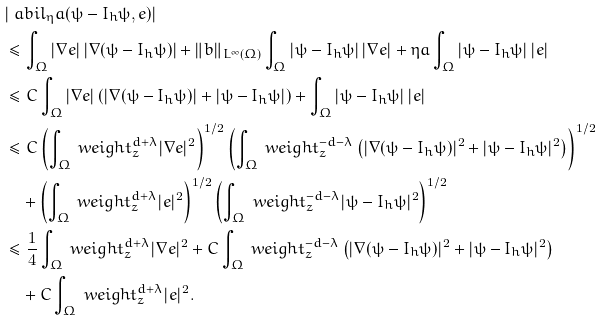Convert formula to latex. <formula><loc_0><loc_0><loc_500><loc_500>& | \ a b i l _ { \eta } a ( \psi - I _ { h } \psi , e ) | \\ & \leq \int _ { \Omega } | \nabla e | \, | \nabla ( \psi - I _ { h } \psi ) | + \| b \| _ { L ^ { \infty } ( \Omega ) } \int _ { \Omega } | \psi - I _ { h } \psi | \, | \nabla e | + \eta a \int _ { \Omega } | \psi - I _ { h } \psi | \, | e | \\ & \leq C \int _ { \Omega } | \nabla e | \left ( | \nabla ( \psi - I _ { h } \psi ) | + | \psi - I _ { h } \psi | \right ) + \int _ { \Omega } | \psi - I _ { h } \psi | \, | e | \\ & \leq C \left ( \int _ { \Omega } \ w e i g h t _ { z } ^ { d + \lambda } | \nabla e | ^ { 2 } \right ) ^ { 1 / 2 } \left ( \int _ { \Omega } \ w e i g h t _ { z } ^ { - d - \lambda } \left ( | \nabla ( \psi - I _ { h } \psi ) | ^ { 2 } + | \psi - I _ { h } \psi | ^ { 2 } \right ) \right ) ^ { 1 / 2 } \\ & \quad + \left ( \int _ { \Omega } \ w e i g h t _ { z } ^ { d + \lambda } | e | ^ { 2 } \right ) ^ { 1 / 2 } \left ( \int _ { \Omega } \ w e i g h t _ { z } ^ { - d - \lambda } | \psi - I _ { h } \psi | ^ { 2 } \right ) ^ { 1 / 2 } \\ & \leq \frac { 1 } { 4 } \int _ { \Omega } \ w e i g h t _ { z } ^ { d + \lambda } | \nabla e | ^ { 2 } + C \int _ { \Omega } \ w e i g h t _ { z } ^ { - d - \lambda } \left ( | \nabla ( \psi - I _ { h } \psi ) | ^ { 2 } + | \psi - I _ { h } \psi | ^ { 2 } \right ) \\ & \quad + C \int _ { \Omega } \ w e i g h t _ { z } ^ { d + \lambda } | e | ^ { 2 } .</formula> 